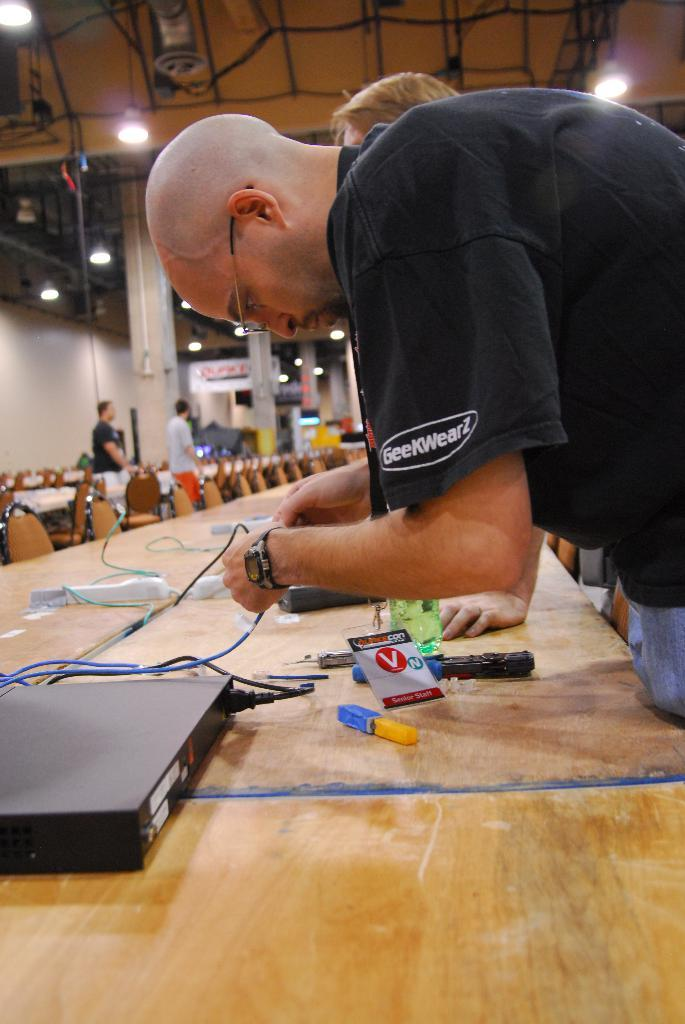How many people are in the image? There are people in the image, but the exact number is not specified. What type of furniture is present in the image? There are chairs and tables in the image. Can you describe any accessories worn by the people in the image? Yes, a person in the image is wearing a watch, and another person is wearing glasses (specs). What type of yoke is being used by the person in the image? There is no yoke present in the image. Can you describe the branch that the person is holding in the image? There is no branch present in the image. 